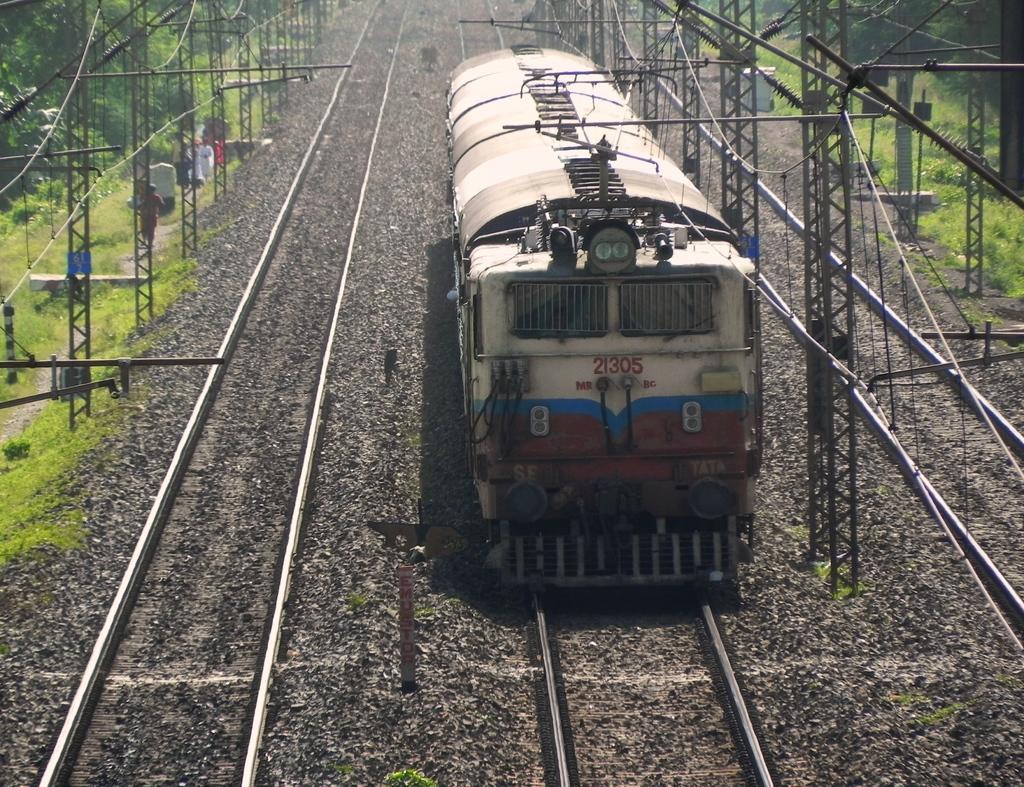Describe this image in one or two sentences. There is a train present on a track as we can see in the middle of this image. We can see poles and trees in the background. 